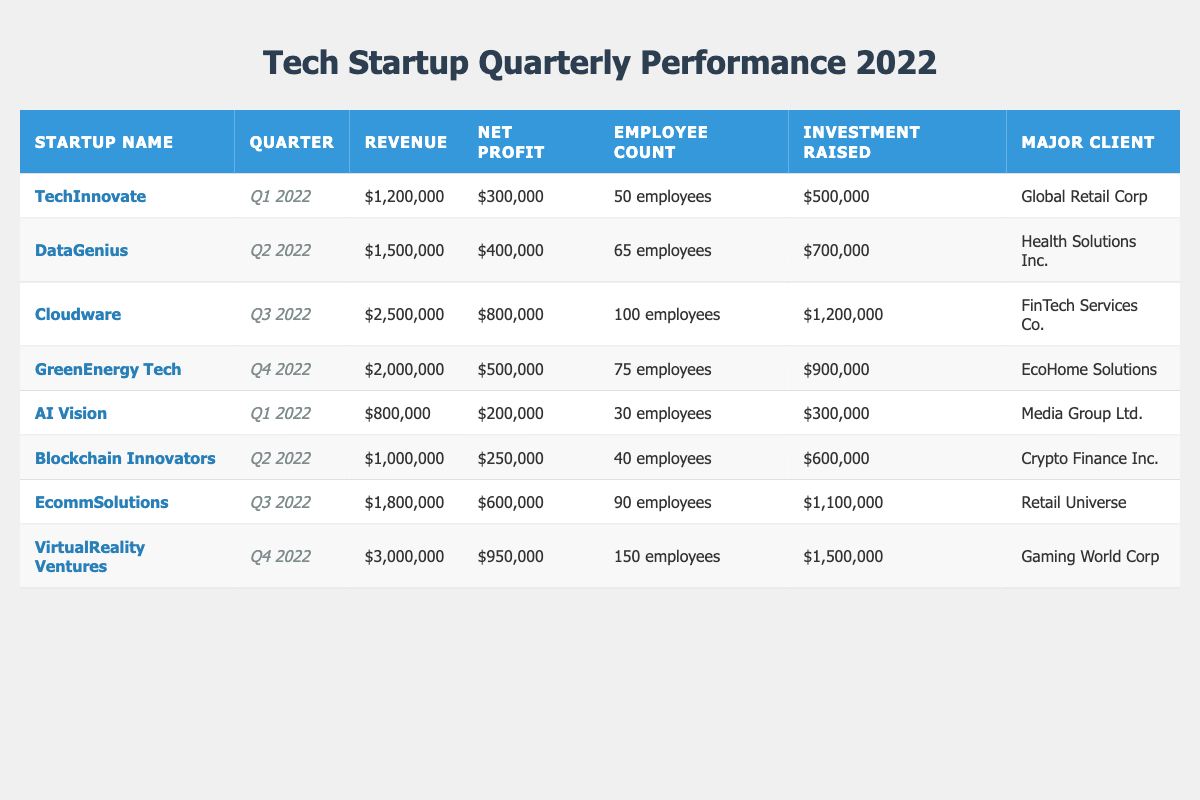What is the total revenue for all startups in Q2 2022? To find the total revenue for Q2 2022, we look at the entries for that quarter. The startups are DataGenius with 1,500,000 and Blockchain Innovators with 1,000,000. Adding these gives us 1,500,000 + 1,000,000 = 2,500,000.
Answer: 2,500,000 Which startup had the highest net profit in Q3 2022? In Q3 2022, we see Cloudware with a net profit of 800,000 and EcommSolutions with 600,000. Comparing these values, Cloudware has the highest net profit at 800,000.
Answer: Cloudware Did any startup raise more than 1 million in investment in Q4 2022? In Q4 2022, VirtualReality Ventures raised 1,500,000 while GreenEnergy Tech raised 900,000. Since 1,500,000 is greater than 1 million, the answer is yes.
Answer: Yes What is the average revenue of startups for the first quarter of 2022? For Q1 2022, we have TechInnovate with 1,200,000 and AI Vision with 800,000. The total revenue is 1,200,000 + 800,000 = 2,000,000. There are 2 startups, so the average revenue is 2,000,000 / 2 = 1,000,000.
Answer: 1,000,000 Which major client did GreenEnergy Tech serve? According to the data for GreenEnergy Tech, their major client is EcoHome Solutions.
Answer: EcoHome Solutions What are the employee counts for startups with a revenue of over 1 million in Q3 2022? In Q3 2022, Cloudware had 100 employees and EcommSolutions had 90 employees. Both had revenues over 1 million: Cloudware at 2,500,000 and EcommSolutions at 1,800,000.
Answer: 100 and 90 Was the net profit of TechInnovate greater than that of AI Vision? TechInnovate reported a net profit of 300,000 while AI Vision reported 200,000. Since 300,000 is greater than 200,000, the answer is yes.
Answer: Yes Who had the least employees among the startups in Q1 2022? In Q1 2022, TechInnovate had 50 employees and AI Vision had 30 employees. Since 30 is less than 50, AI Vision has the least employees for that quarter.
Answer: AI Vision What is the difference in net profit between Cloudware and VirtualReality Ventures? Cloudware reported a net profit of 800,000, while VirtualReality Ventures had a net profit of 950,000. The difference is 950,000 - 800,000 = 150,000.
Answer: 150,000 